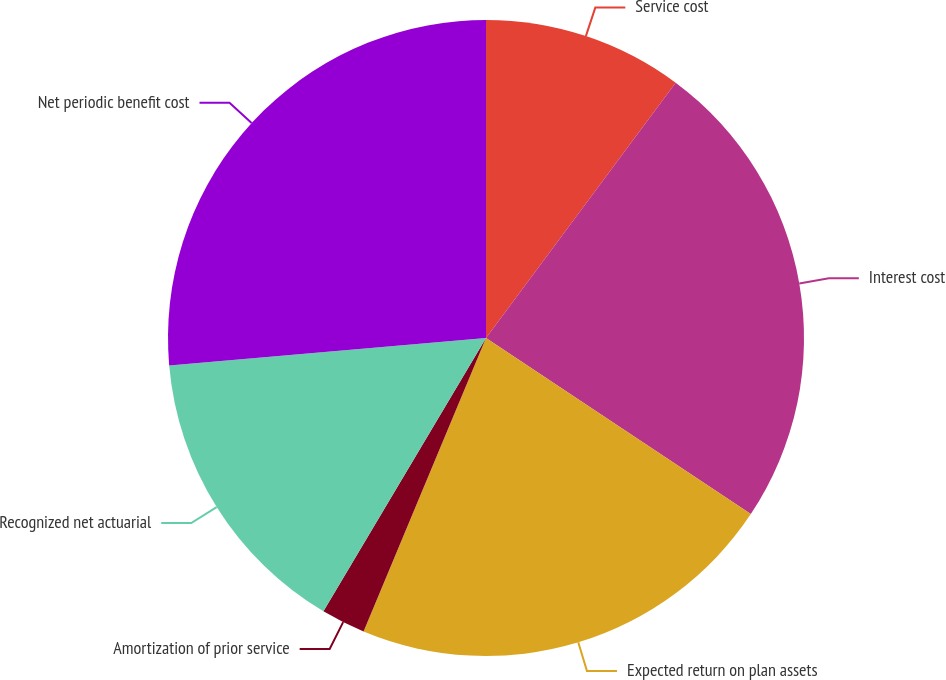Convert chart to OTSL. <chart><loc_0><loc_0><loc_500><loc_500><pie_chart><fcel>Service cost<fcel>Interest cost<fcel>Expected return on plan assets<fcel>Amortization of prior service<fcel>Recognized net actuarial<fcel>Net periodic benefit cost<nl><fcel>10.17%<fcel>24.17%<fcel>21.95%<fcel>2.25%<fcel>15.08%<fcel>26.38%<nl></chart> 